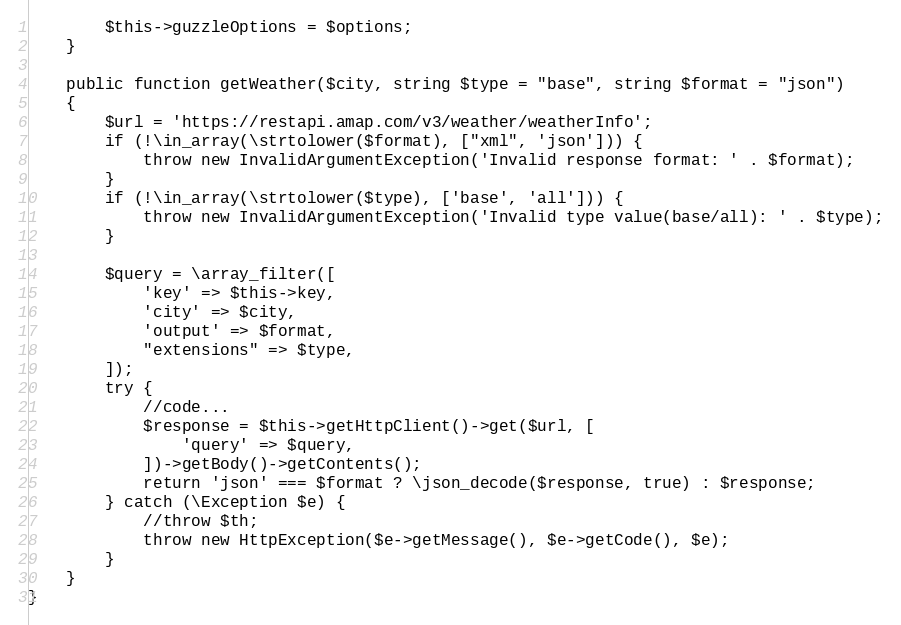<code> <loc_0><loc_0><loc_500><loc_500><_PHP_>        $this->guzzleOptions = $options;
    }

    public function getWeather($city, string $type = "base", string $format = "json")
    {
        $url = 'https://restapi.amap.com/v3/weather/weatherInfo';
        if (!\in_array(\strtolower($format), ["xml", 'json'])) {
            throw new InvalidArgumentException('Invalid response format: ' . $format);
        }
        if (!\in_array(\strtolower($type), ['base', 'all'])) {
            throw new InvalidArgumentException('Invalid type value(base/all): ' . $type);
        }

        $query = \array_filter([
            'key' => $this->key,
            'city' => $city,
            'output' => $format,
            "extensions" => $type,
        ]);
        try {
            //code...
            $response = $this->getHttpClient()->get($url, [
                'query' => $query,
            ])->getBody()->getContents();
            return 'json' === $format ? \json_decode($response, true) : $response;
        } catch (\Exception $e) {
            //throw $th;
            throw new HttpException($e->getMessage(), $e->getCode(), $e);
        }
    }
}
</code> 